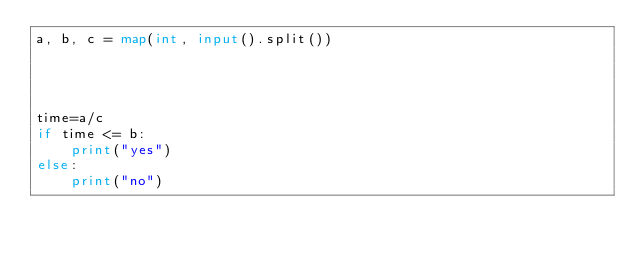<code> <loc_0><loc_0><loc_500><loc_500><_Python_>a, b, c = map(int, input().split())




time=a/c
if time <= b:
    print("yes")
else:
    print("no")






</code> 